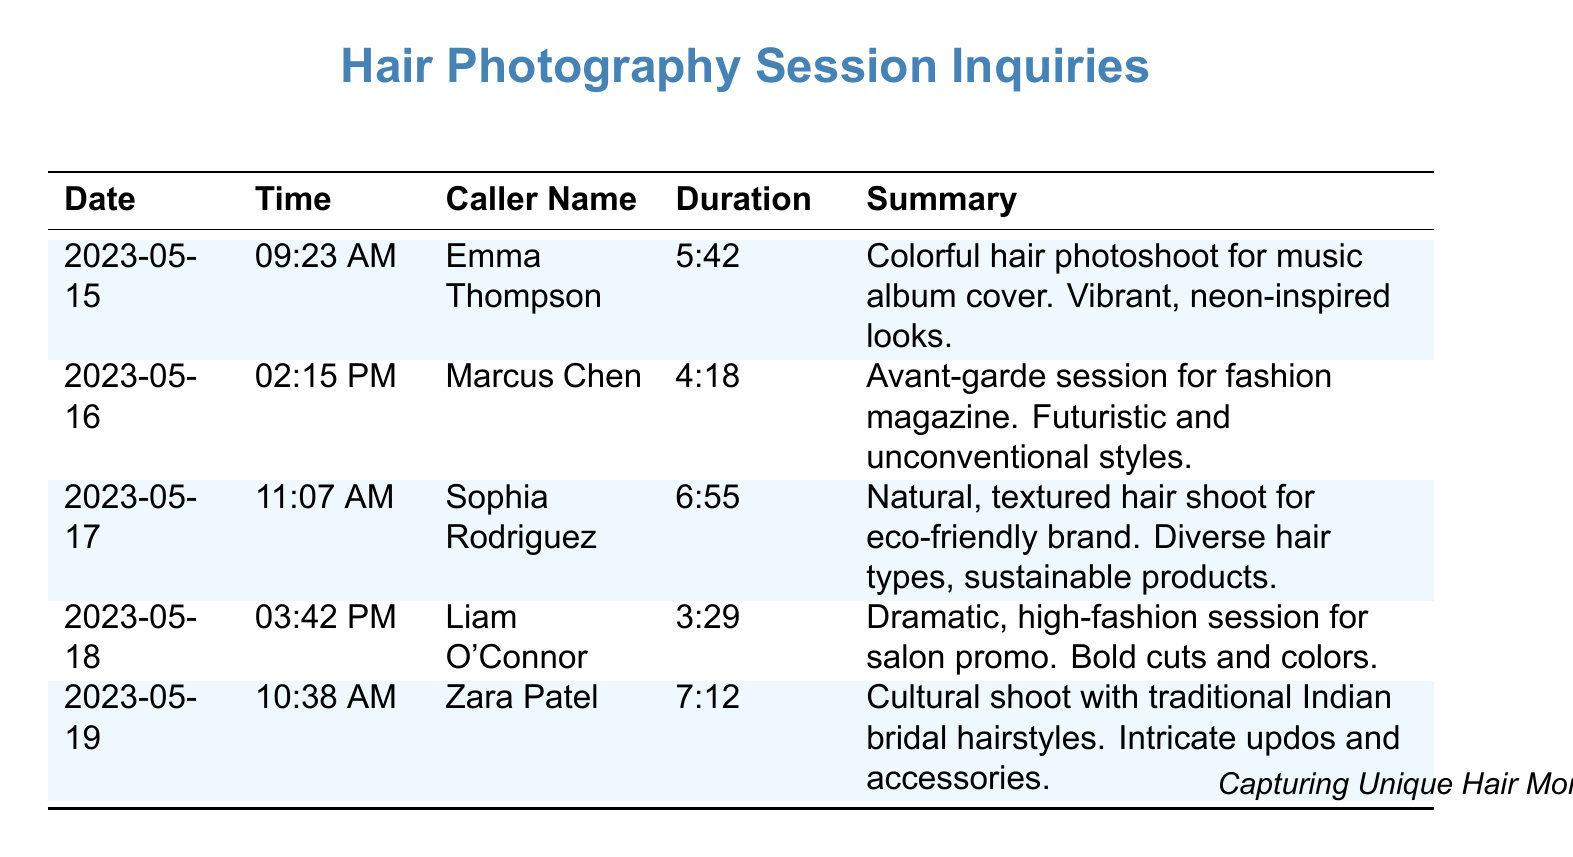What is the date of Emma Thompson's call? The date of Emma Thompson's call is listed in the document, which states that it was on May 15, 2023.
Answer: May 15, 2023 How long was the call with Liam O'Connor? The duration of the call with Liam O'Connor is provided in the document, which shows it was 3 minutes and 29 seconds.
Answer: 3:29 What type of shoot did Sophia Rodriguez inquire about? The document specifies that Sophia Rodriguez requested a natural, textured hair shoot for an eco-friendly brand.
Answer: Natural, textured hair shoot How many clients are listed in total? The document includes five clients who made inquiries for hair photography sessions.
Answer: 5 What was the theme of Zara Patel's hair shoot? The document mentions that Zara Patel's shoot involved cultural traditional Indian bridal hairstyles, indicating the theme.
Answer: Traditional Indian bridal hairstyles Which caller requested a session for a fashion magazine? The document specifies that Marcus Chen requested an avant-garde session for a fashion magazine.
Answer: Marcus Chen What was the duration of the call with Emma Thompson? The document states that Emma Thompson's call lasted 5 minutes and 42 seconds.
Answer: 5:42 Which date had the longest call duration? The document shows that the longest call was with Sophia Rodriguez on May 17, lasting 6 minutes and 55 seconds.
Answer: May 17 